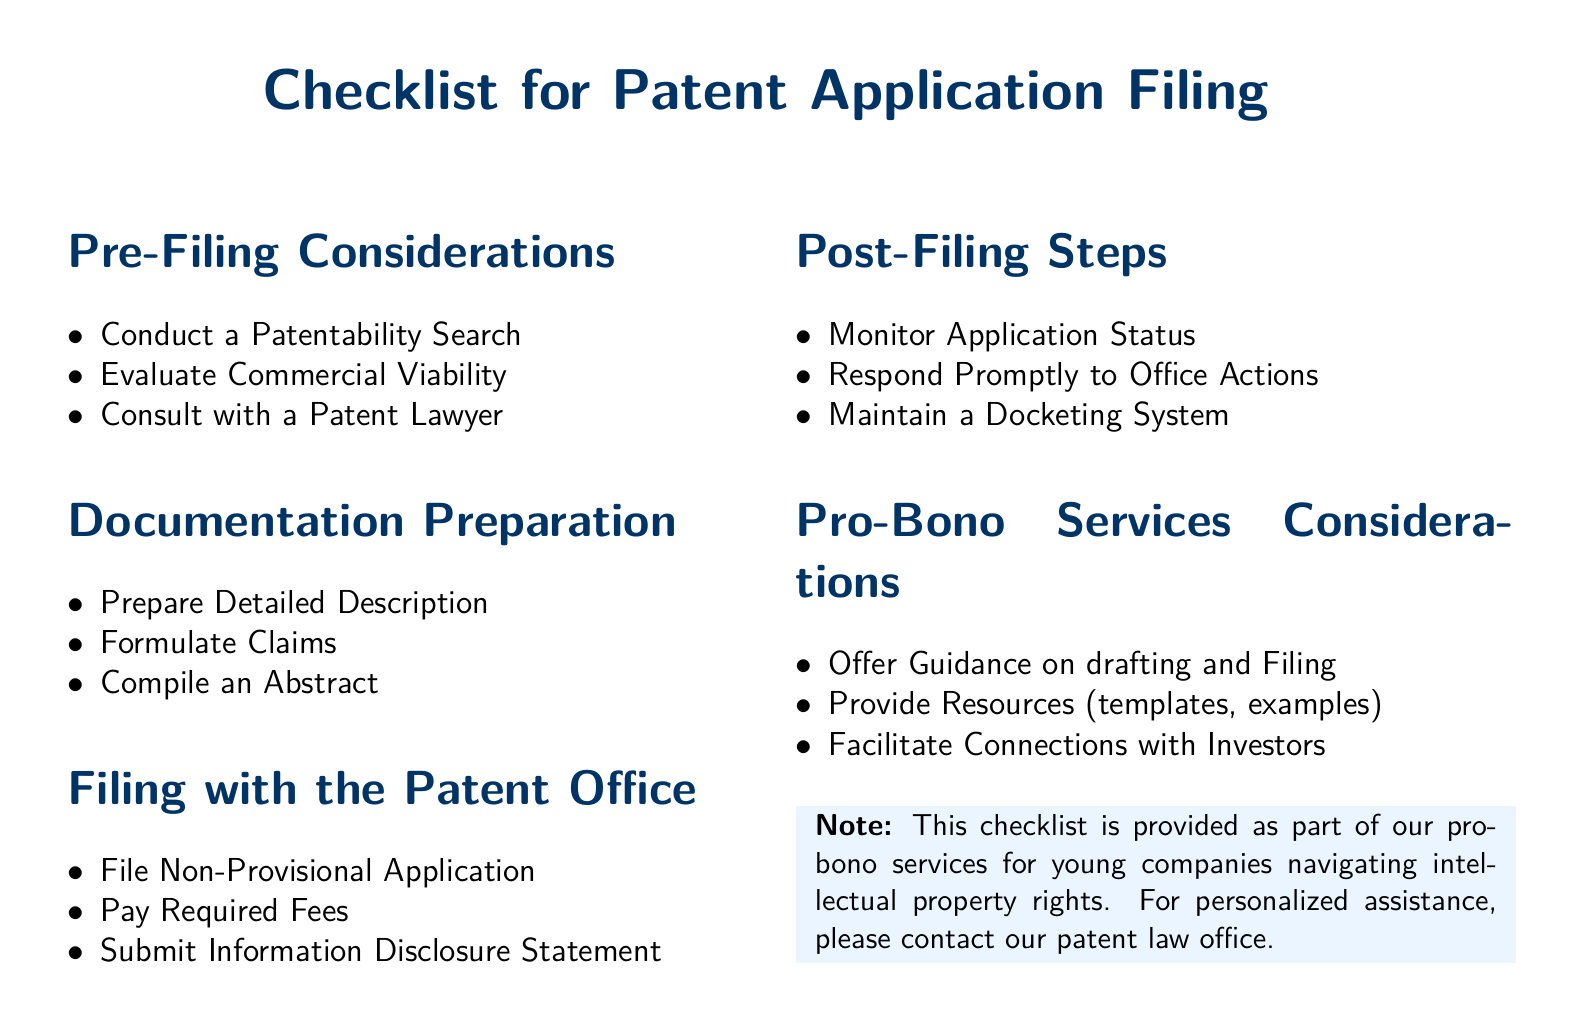What is the title of the document? The title of the document is displayed prominently at the top and indicates the purpose of the information within.
Answer: Checklist for Patent Application Filing How many sections are there in the document? The document contains multiple sections that are clearly labeled and organized for easy reference.
Answer: Five What is the first item listed under "Pre-Filing Considerations"? The first item is listed as part of the initial steps a company should take before filing a patent application.
Answer: Conduct a Patentability Search What must be paid when filing a non-provisional application? The document specifies a requirement associated with the filing process that involves a financial obligation.
Answer: Required Fees What is one of the "Post-Filing Steps"? The document lists steps to follow after the application has been submitted, indicating ongoing responsibilities.
Answer: Monitor Application Status What type of service is provided as part of the pro-bono offerings? The document outlines the nature of assistance available to companies seeking help with their patent applications.
Answer: Guidance on drafting and Filing 